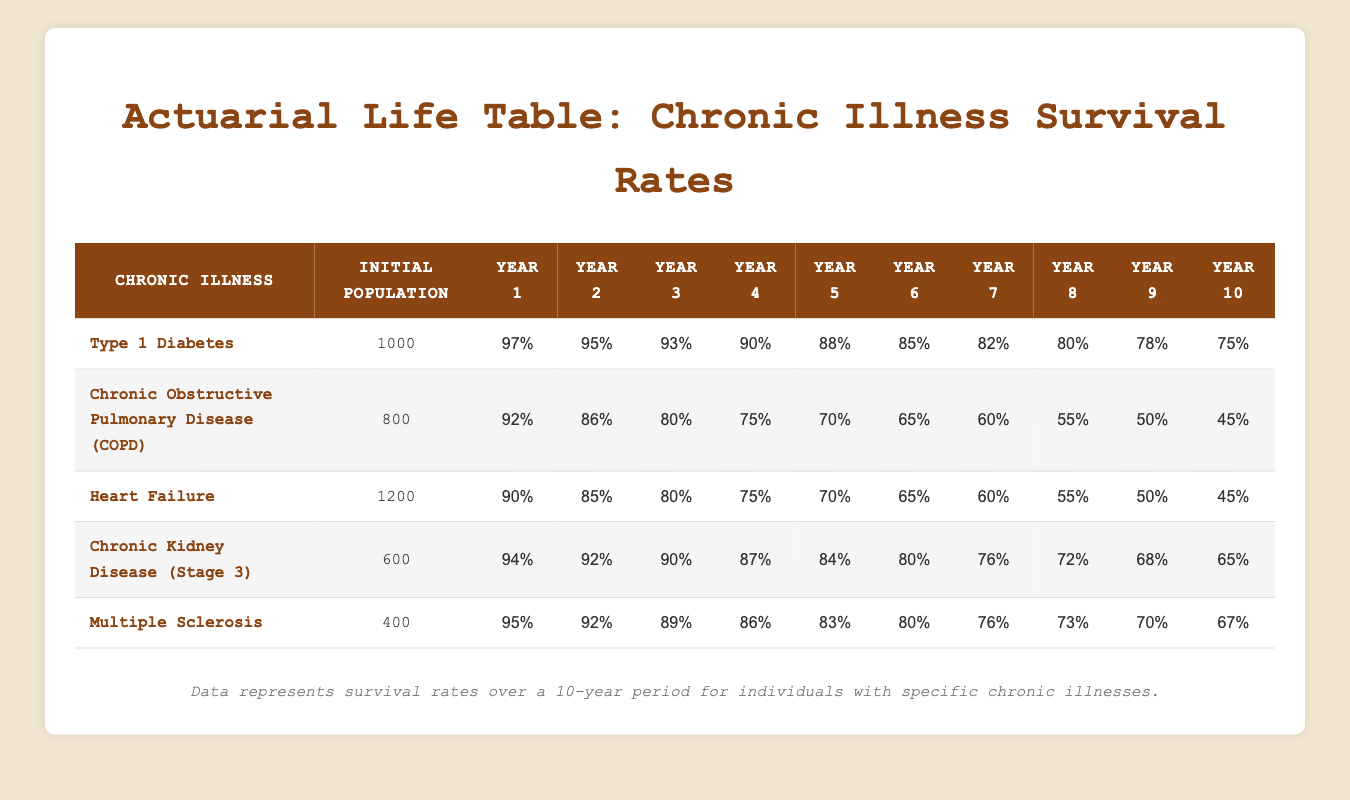What is the initial population for Chronic Kidney Disease? According to the table, the initial population listed for Chronic Kidney Disease (Stage 3) is 600 individuals.
Answer: 600 What is the survival rate for Multiple Sclerosis in year 5? The table indicates the survival rate for Multiple Sclerosis in year 5 is 83%.
Answer: 83% Which chronic illness has the highest survival rate in year 1? By comparing the year 1 survival rates, Multiple Sclerosis has the highest at 95%, while Type 1 Diabetes has 97%. Thus, Type 1 Diabetes has the highest survival rate.
Answer: Type 1 Diabetes Calculate the average survival rate for Heart Failure over the 10 years. The survival rates for Heart Failure from year 1 to year 10 are: 90%, 85%, 80%, 75%, 70%, 65%, 60%, 55%, 50%, and 45%. Adding these gives a total of 825%. Dividing by 10 years results in an average survival rate of 82.5%.
Answer: 82.5% Is it true that the survival rate for COPD decreases by more than 10% in the first 3 years? Evaluating the survival rates for COPD: year 1 is 92% and year 3 is 80%. The decrease from year 1 to year 3 is 12%, therefore, it is true that the decline exceeds 10%.
Answer: Yes What is the difference in year 10 survival rates between Chronic Kidney Disease and Type 1 Diabetes? The survival rate for Chronic Kidney Disease in year 10 is 65% and for Type 1 Diabetes it is 75%. The difference is 75% - 65% = 10%.
Answer: 10% Which chronic illness has the lowest survival rate by year 10? Reviewing the year 10 survival rates, COPD has the lowest rate at 45%, while Heart Failure has 45%, but they are equal. Both are the lowest.
Answer: COPD and Heart Failure In which year does Type 1 Diabetes experience a survival rate decline below 80%? The survival rate for Type 1 Diabetes drops below 80% starting in year 8, where it reaches 80%. In year 9, it falls to 78%. Hence, it declines below 80% in year 9.
Answer: Year 9 What is the total decline in survival rate for Chronic Kidney Disease from year 1 to year 10? The survival rate for Chronic Kidney Disease in year 1 is 94% and in year 10 is 65%. The total decline is 94% - 65%, equating to a decline of 29%.
Answer: 29% 